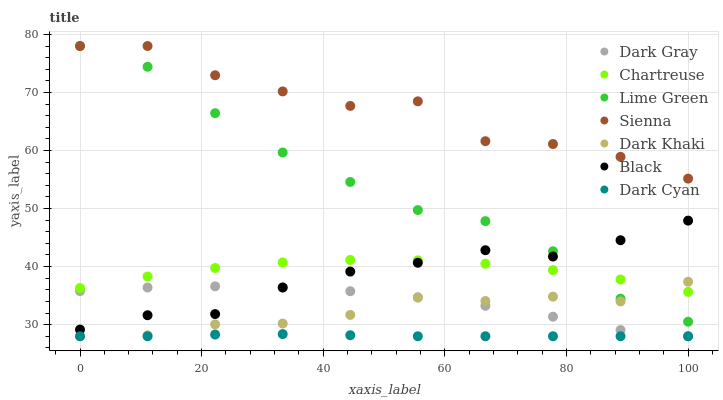Does Dark Cyan have the minimum area under the curve?
Answer yes or no. Yes. Does Sienna have the maximum area under the curve?
Answer yes or no. Yes. Does Dark Gray have the minimum area under the curve?
Answer yes or no. No. Does Dark Gray have the maximum area under the curve?
Answer yes or no. No. Is Dark Cyan the smoothest?
Answer yes or no. Yes. Is Sienna the roughest?
Answer yes or no. Yes. Is Dark Gray the smoothest?
Answer yes or no. No. Is Dark Gray the roughest?
Answer yes or no. No. Does Dark Gray have the lowest value?
Answer yes or no. Yes. Does Chartreuse have the lowest value?
Answer yes or no. No. Does Lime Green have the highest value?
Answer yes or no. Yes. Does Dark Gray have the highest value?
Answer yes or no. No. Is Dark Khaki less than Sienna?
Answer yes or no. Yes. Is Sienna greater than Chartreuse?
Answer yes or no. Yes. Does Lime Green intersect Sienna?
Answer yes or no. Yes. Is Lime Green less than Sienna?
Answer yes or no. No. Is Lime Green greater than Sienna?
Answer yes or no. No. Does Dark Khaki intersect Sienna?
Answer yes or no. No. 